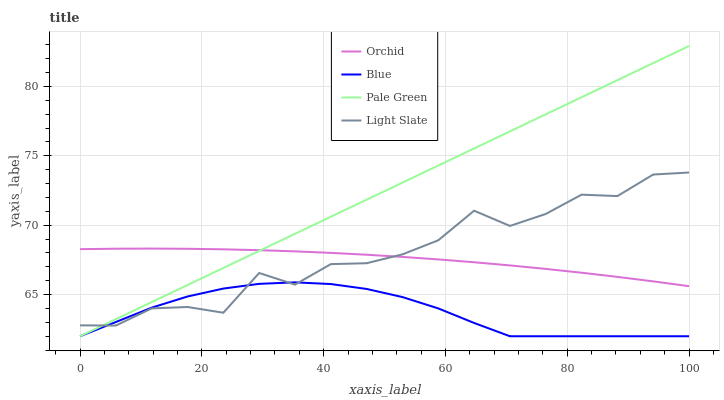Does Blue have the minimum area under the curve?
Answer yes or no. Yes. Does Pale Green have the maximum area under the curve?
Answer yes or no. Yes. Does Light Slate have the minimum area under the curve?
Answer yes or no. No. Does Light Slate have the maximum area under the curve?
Answer yes or no. No. Is Pale Green the smoothest?
Answer yes or no. Yes. Is Light Slate the roughest?
Answer yes or no. Yes. Is Light Slate the smoothest?
Answer yes or no. No. Is Pale Green the roughest?
Answer yes or no. No. Does Blue have the lowest value?
Answer yes or no. Yes. Does Light Slate have the lowest value?
Answer yes or no. No. Does Pale Green have the highest value?
Answer yes or no. Yes. Does Light Slate have the highest value?
Answer yes or no. No. Is Blue less than Orchid?
Answer yes or no. Yes. Is Orchid greater than Blue?
Answer yes or no. Yes. Does Light Slate intersect Orchid?
Answer yes or no. Yes. Is Light Slate less than Orchid?
Answer yes or no. No. Is Light Slate greater than Orchid?
Answer yes or no. No. Does Blue intersect Orchid?
Answer yes or no. No. 